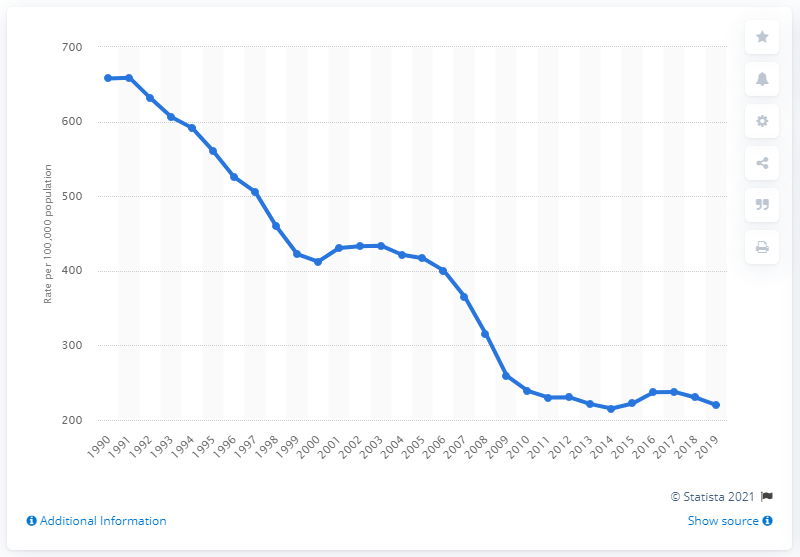Point out several critical features in this image. According to reported data, the motor vehicle theft rate per 100,000 people in the United States was 219.9 in 2019. 